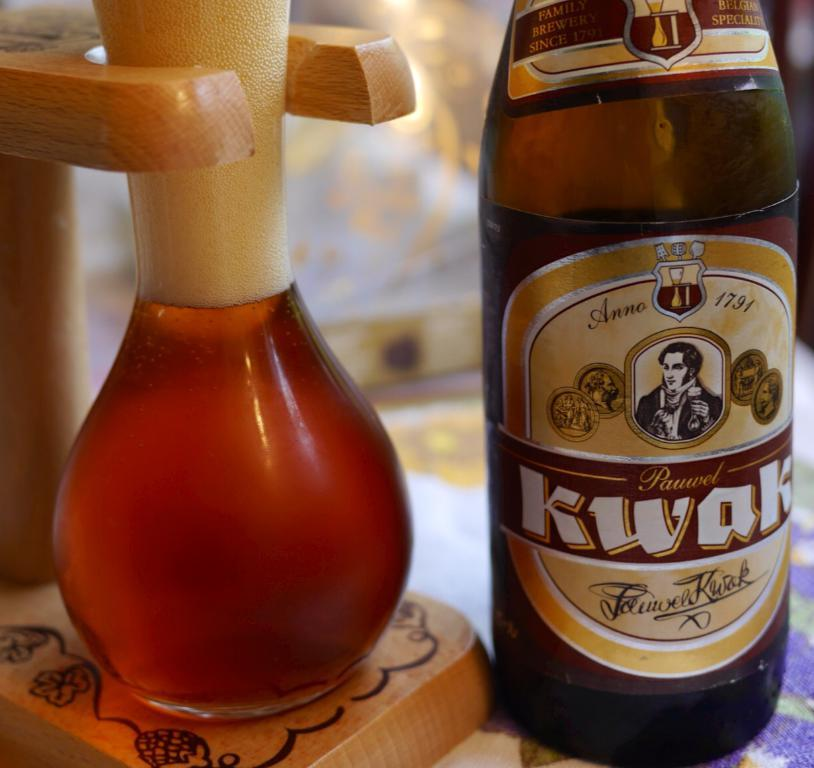<image>
Provide a brief description of the given image. A bottle has the year 1791 on the label and is next to a filled glass. 